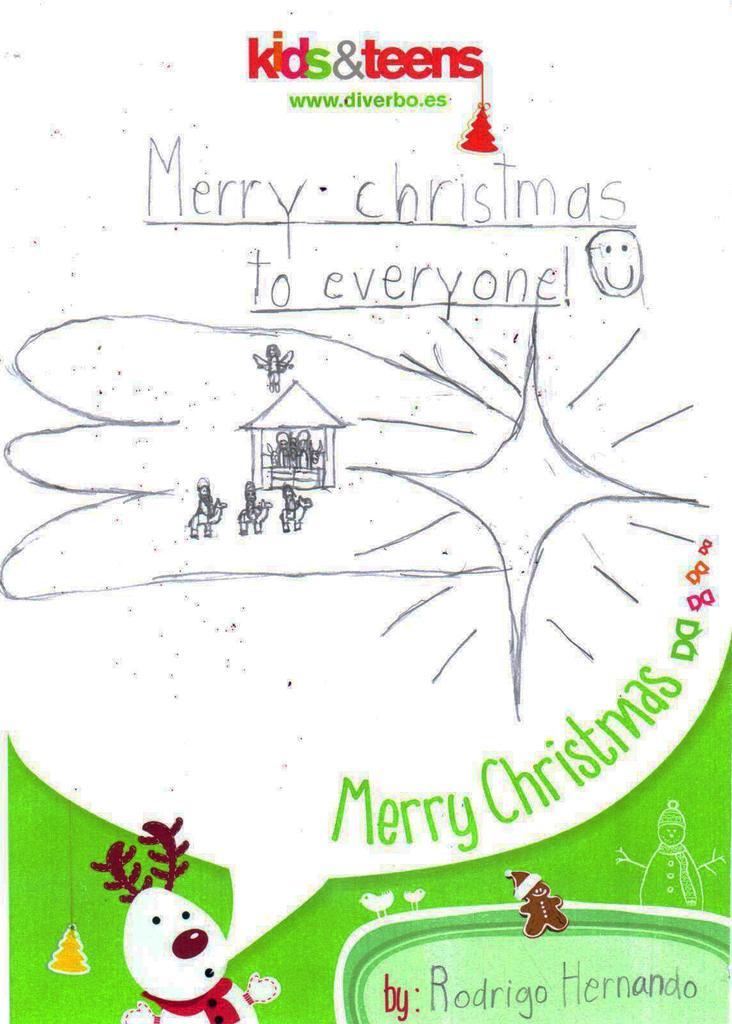Can you describe this image briefly? In this image there is a greeting card. At the bottom there is a cartoon and we can see text written on the greeting card. 